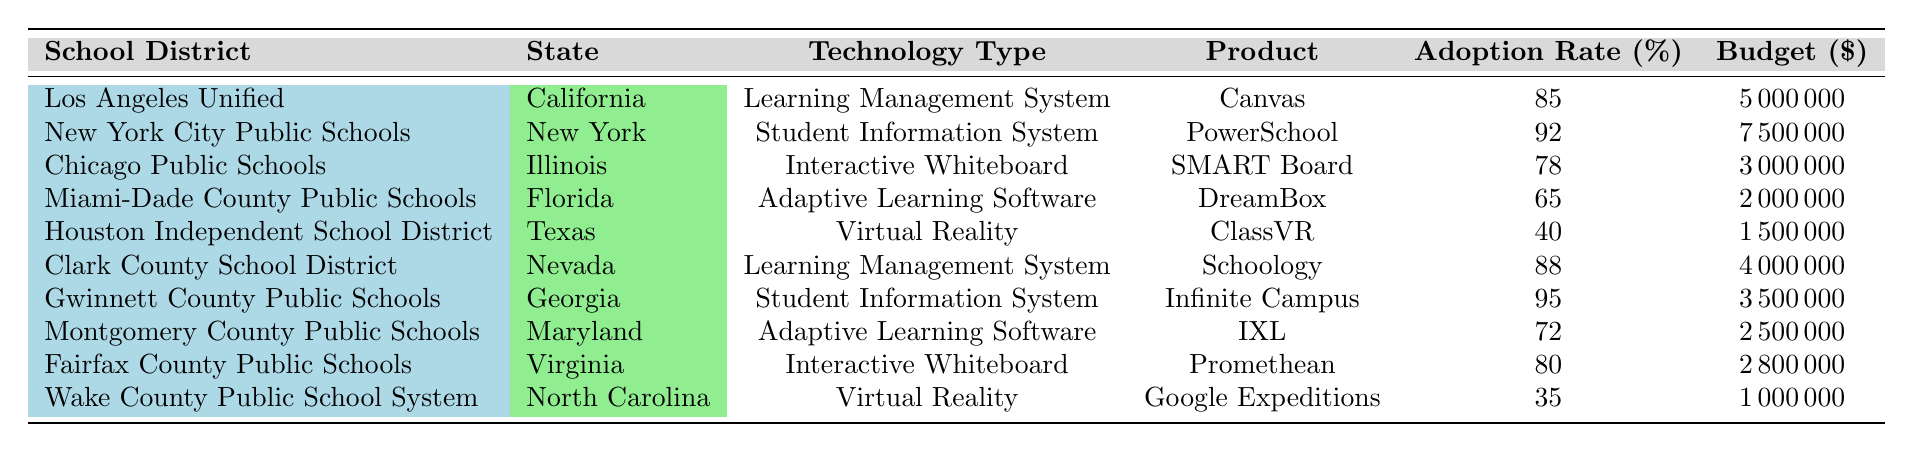What is the adoption rate of Canvas in Los Angeles Unified? According to the table, the adoption rate for Canvas in Los Angeles Unified is directly listed under the Adoption Rate column for that district. The specific value is stated as 85%.
Answer: 85% Which state has the highest adoption rate for student information systems? By examining the adoption rates of student information systems in the table, New York (with PowerSchool) has an adoption rate of 92%, while Georgia (with Infinite Campus) has an adoption rate of 95%. Comparing both shows that Georgia has the highest at 95%.
Answer: Georgia What is the total budget allocated for the use of adaptive learning software across the districts? To find the total budget allocated for adaptive learning software, add the budgets of Miami-Dade County Public Schools (2,000,000) and Montgomery County Public Schools (2,500,000). The calculation is 2,000,000 + 2,500,000 = 4,500,000.
Answer: 4,500,000 Is there any district that has an adoption rate below 50%? Checking the adoption rates in the table shows that the lowest rate is 35% for Wake County Public School System with Google Expeditions. Hence, there is a district with an adoption rate below 50%.
Answer: Yes What is the average adoption rate for interactive whiteboards across the districts listed? The adoption rates for interactive whiteboards are 78% (Chicago Public Schools) and 80% (Fairfax County Public Schools). To find the average adoption rate, sum these rates (78 + 80 = 158) and divide by the number of districts (2). Therefore, 158/2 = 79%.
Answer: 79% Which technology type has the highest average adoption rate? The adoption rates for each technology type are: Learning Management System (85% and 88%), Student Information System (92% and 95%), Interactive Whiteboard (78% and 80%), Adaptive Learning Software (65% and 72%), and Virtual Reality (40% and 35%). Computing the average for each type gives: LMS (86.5%), SIS (93.5%), IWB (79%), ALS (68.5%), and VR (37.5%). The Student Information System has the highest average at 93.5%.
Answer: Student Information System What is the difference in budget between the districts with the highest and lowest adoption rates? The district with the highest adoption rate is Gwinnett County Public Schools with a budget of 3,500,000 and the district with the lowest is Wake County Public School System with a budget of 1,000,000. The difference is 3,500,000 - 1,000,000 = 2,500,000.
Answer: 2,500,000 Is Miami-Dade County Public Schools using a learning management system? Looking at the table, Miami-Dade County Public Schools is listed under adaptive learning software, not under learning management systems. Therefore, they are not using a learning management system.
Answer: No 